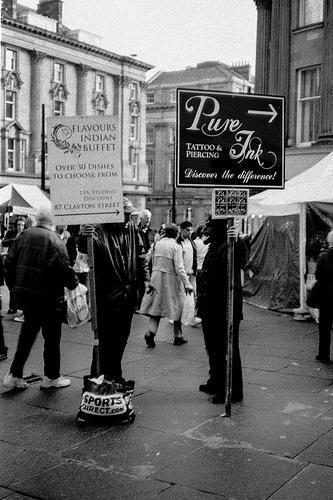How many signs are there?
Give a very brief answer. 2. 